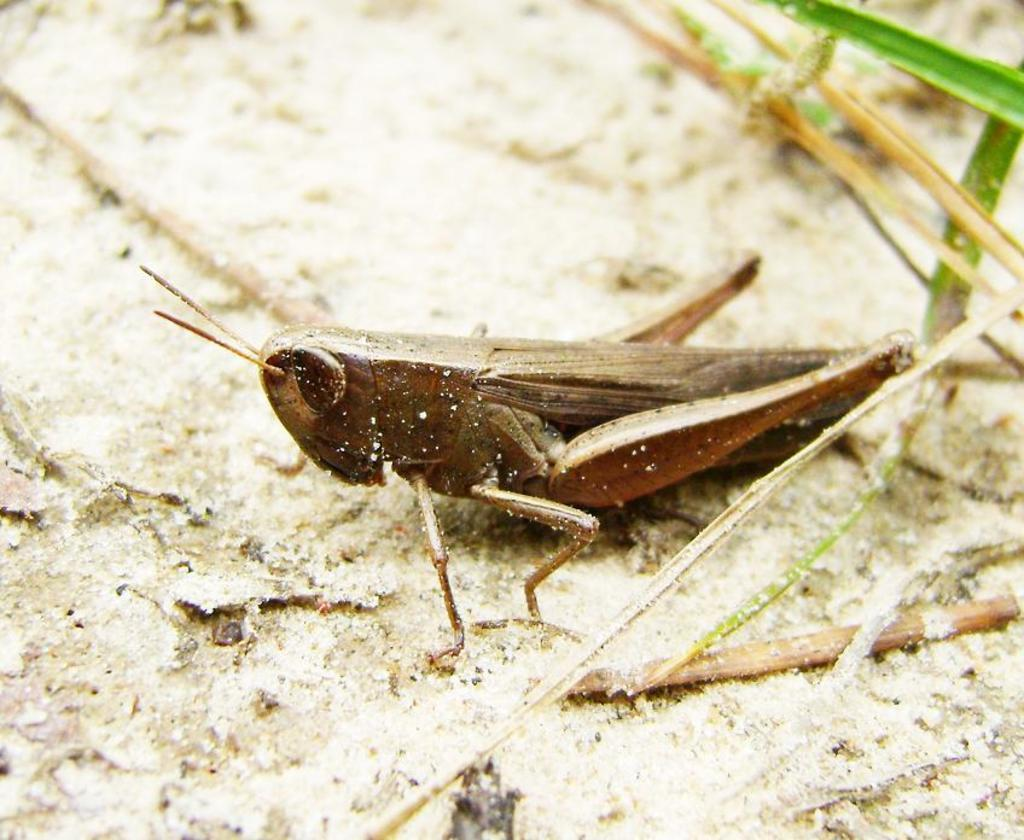What type of creature is present in the image? There is an insect in the image. What is the color of the insect? The insect is brown in color. What are some distinct features of the insect? The insect has long legs and antenna. What type of vegetation is visible in the image? There are grass plants in the image. What type of competition is the insect participating in within the image? There is no competition present in the image; it simply shows an insect with long legs and antenna among grass plants. 